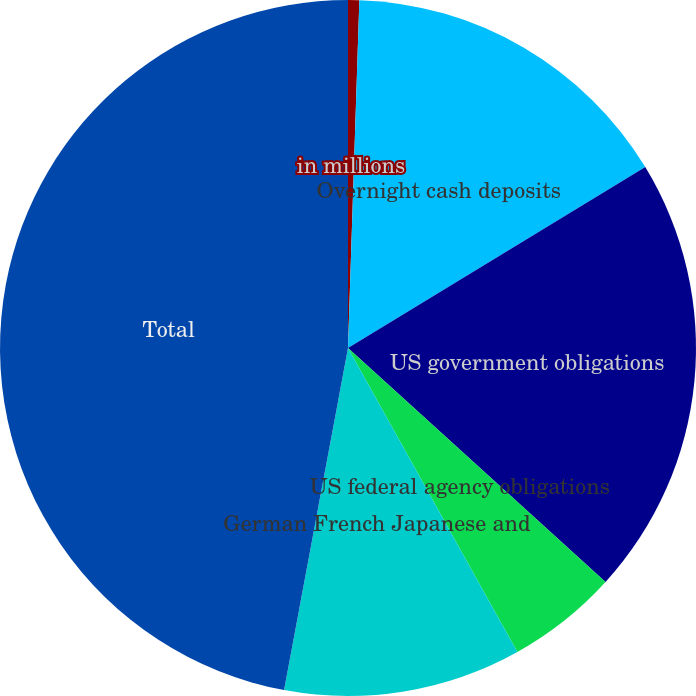Convert chart to OTSL. <chart><loc_0><loc_0><loc_500><loc_500><pie_chart><fcel>in millions<fcel>Overnight cash deposits<fcel>US government obligations<fcel>US federal agency obligations<fcel>German French Japanese and<fcel>Total<nl><fcel>0.52%<fcel>15.78%<fcel>20.44%<fcel>5.17%<fcel>11.03%<fcel>47.06%<nl></chart> 